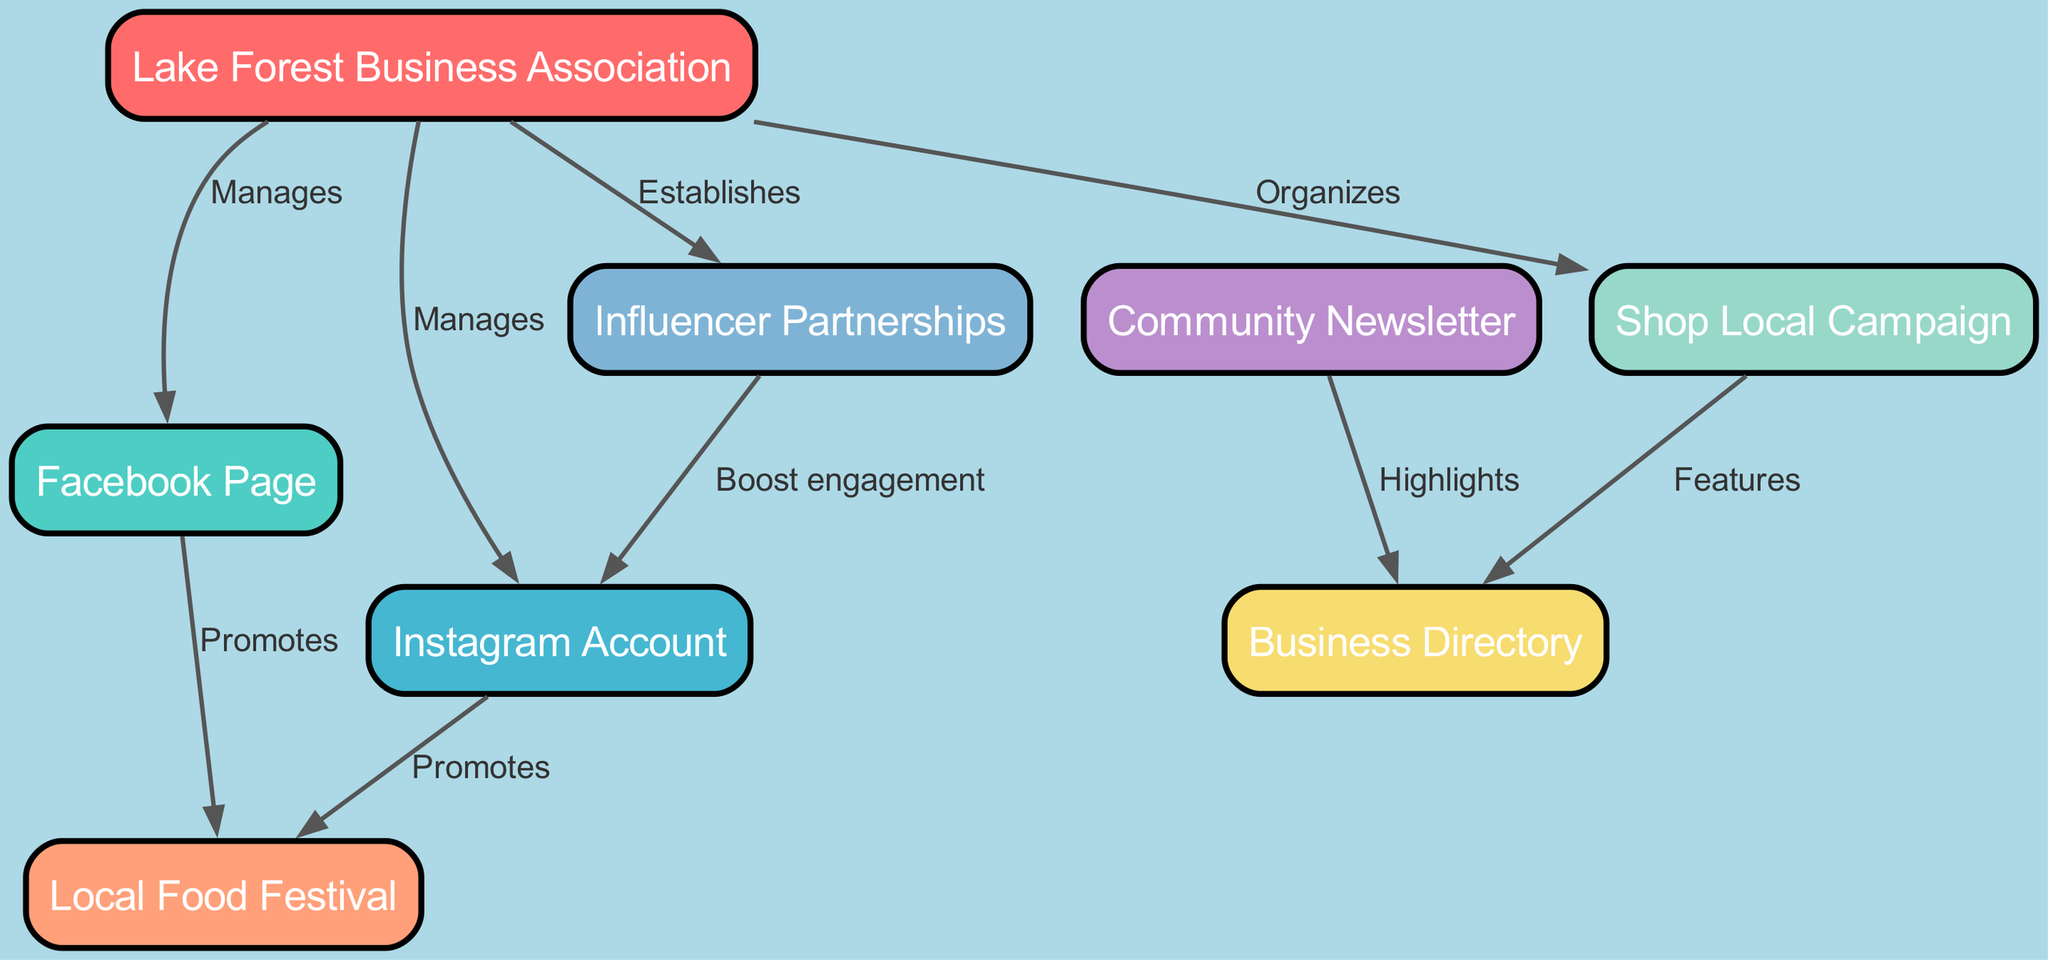What is the total number of nodes in the diagram? By counting the entries in the "nodes" section of the data, there are eight distinct nodes listed: Lake Forest Business Association, Facebook Page, Instagram Account, Local Food Festival, Shop Local Campaign, Business Directory, Community Newsletter, and Influencer Partnerships.
Answer: Eight Which node manages the Facebook Page? The edge from "Lake Forest Business Association" to "Facebook Page" labeled as "Manages" indicates that the Lake Forest Business Association is responsible for managing the Facebook Page.
Answer: Lake Forest Business Association How many edges are directed from the Instagram Account? The edges stemming from "Instagram Account" are counted; it shows that there is one edge directed towards the "Local Food Festival" with the label "Promotes."
Answer: One What type of campaign does the Lake Forest Business Association organize? The edge labeled as "Organizes" from "Lake Forest Business Association" to "Shop Local Campaign" shows that the organization is responsible for this type of campaign.
Answer: Shop Local Campaign Which two nodes are connected by the label "Highlights"? The edge labeled as "Highlights" indicates the connection from "Community Newsletter" to "Business Directory." Thus, these two nodes are directly connected by this label.
Answer: Community Newsletter and Business Directory What is the purpose of the Influencer Partnerships in relation to the Instagram Account? The edge linking "Influencer Partnerships" to "Instagram Account" produces the label "Boost engagement," indicating that the purpose is to enhance engagement on the Instagram account.
Answer: Boost engagement How many promotional connections does the Facebook Page have? By examining the edges, the "Facebook Page" has one directed edge leading to "Local Food Festival," labeled "Promotes." This makes it a single promotional connection.
Answer: One Which node features the Business Directory as part of a campaign? The directed edge from "Shop Local Campaign" to "Business Directory" indicates that the Business Directory is featured as part of the Shop Local Campaign efforts.
Answer: Shop Local Campaign Which node establishes partnerships with influencers? The edge from "Lake Forest Business Association" to "Influencer Partnerships" with the label "Establishes" clearly indicates that the Business Association is responsible for establishing influencer partnerships.
Answer: Lake Forest Business Association 